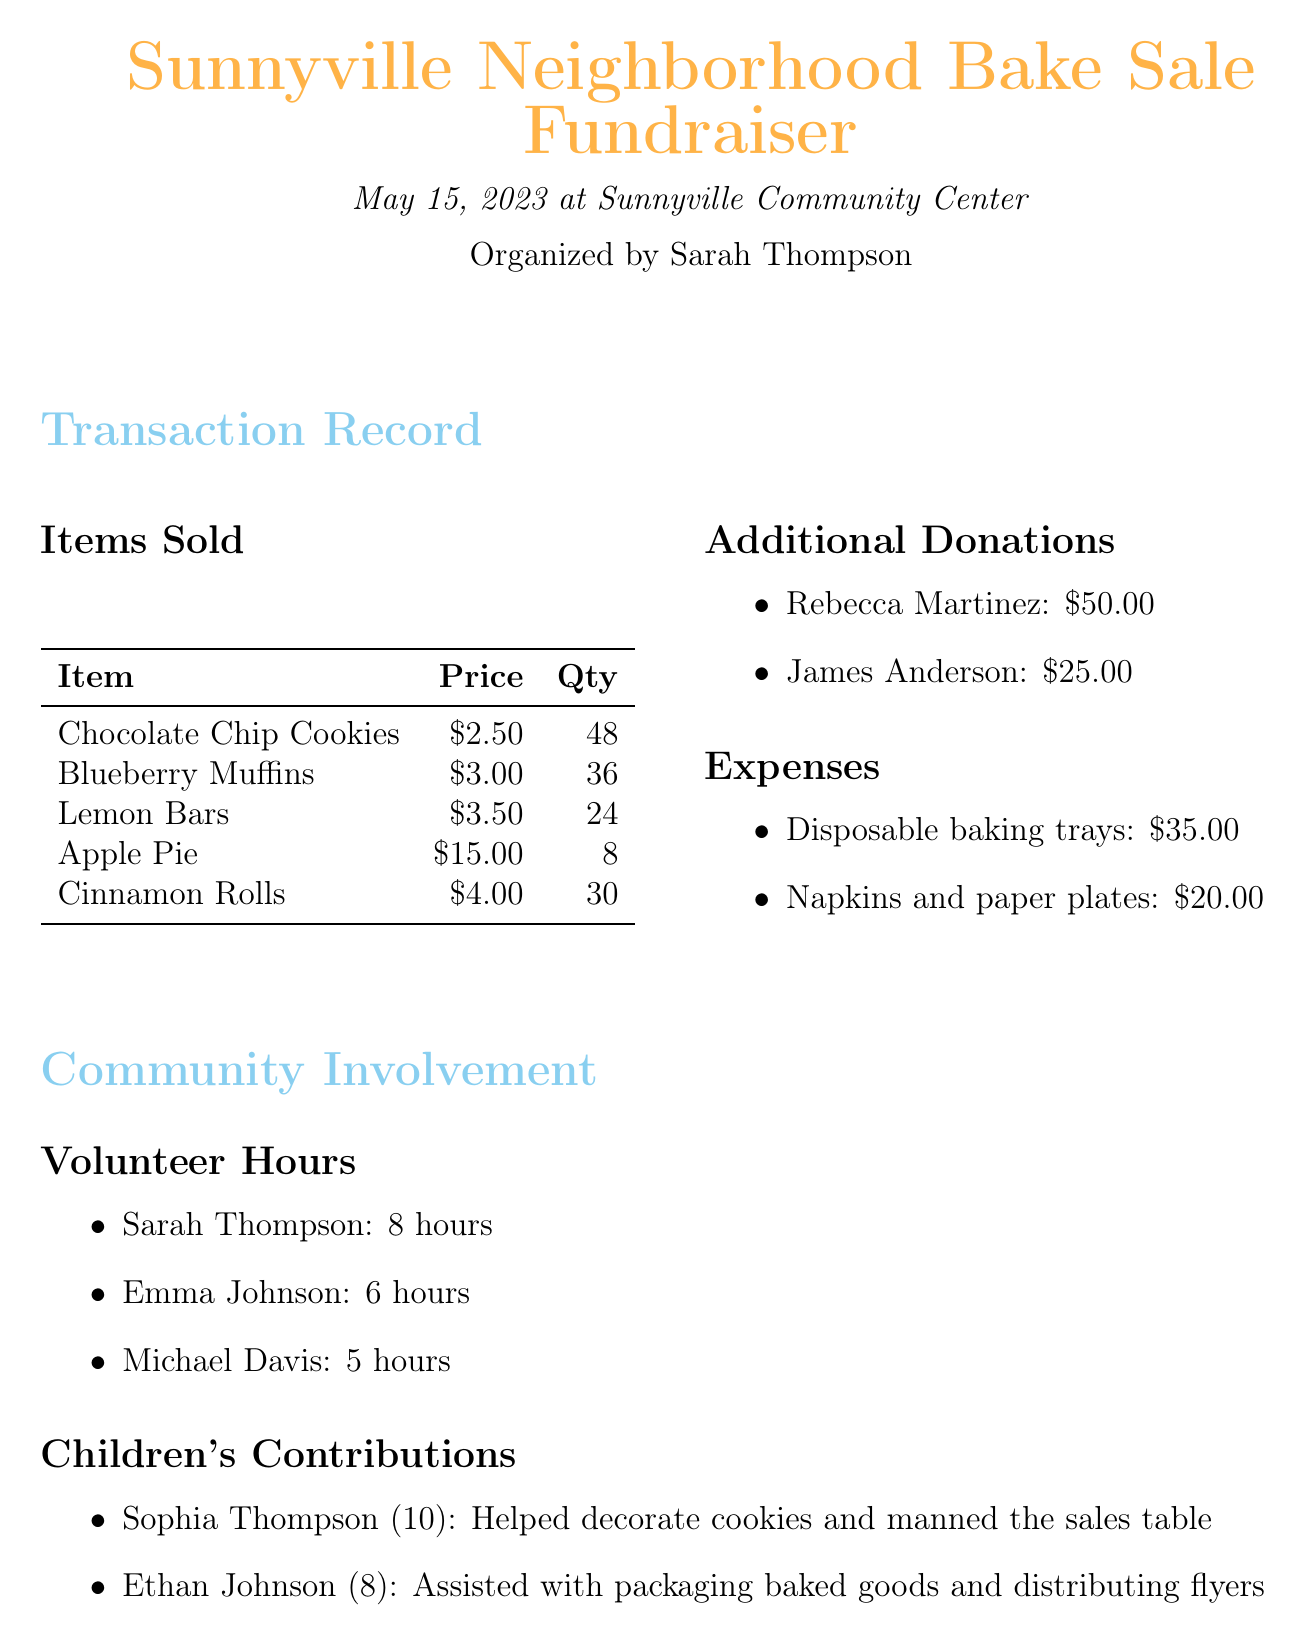What is the name of the event? The name of the event is provided in the document under the event details section.
Answer: Sunnyville Neighborhood Bake Sale Fundraiser Who is the organizer of the bake sale? The organizer's name is listed in the event details section of the document.
Answer: Sarah Thompson How many units of Lemon Bars were sold? The number of units sold for Lemon Bars can be found in the items sold section.
Answer: 24 What is the total amount raised for the community center? The total amount raised is summarized at the end of the document based on all sales and donations minus expenses.
Answer: $541.00 Who donated $50.00? The name of the donor is mentioned in the additional donations section.
Answer: Rebecca Martinez What is the cost of disposable baking trays? The cost can be found in the expenses section of the document.
Answer: $35.00 How many hours did Emma Johnson volunteer? The number of hours volunteered by Emma Johnson is mentioned in the volunteer hours section.
Answer: 6 hours What contribution did Sophia Thompson make? The contribution made by Sophia Thompson is described in the children's contributions section.
Answer: Helped decorate cookies and manned the sales table How many Blueberry Muffins were sold? The number of Blueberry Muffins sold is provided in the items sold section.
Answer: 36 